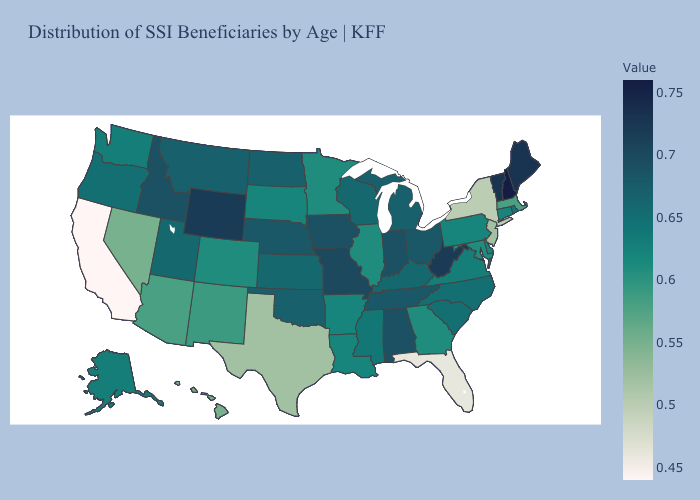Among the states that border Alabama , which have the lowest value?
Be succinct. Florida. Does West Virginia have the highest value in the South?
Quick response, please. Yes. Which states have the lowest value in the West?
Short answer required. California. 